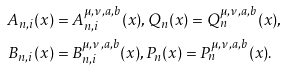Convert formula to latex. <formula><loc_0><loc_0><loc_500><loc_500>A _ { n , i } ( x ) & = A _ { n , i } ^ { \mu , \nu , a , b } ( x ) , Q _ { n } ( x ) = Q _ { n } ^ { \mu , \nu , a , b } ( x ) , \\ B _ { n , i } ( x ) & = B _ { n , i } ^ { \mu , \nu , a , b } ( x ) , P _ { n } ( x ) = P _ { n } ^ { \mu , \nu , a , b } ( x ) .</formula> 